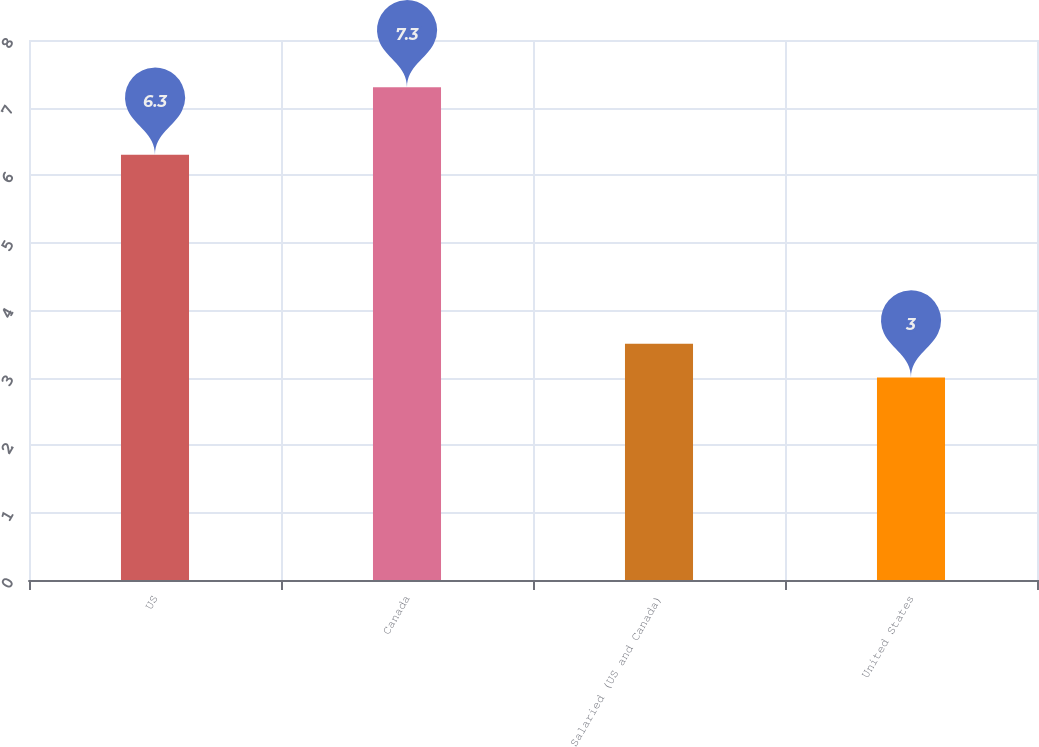<chart> <loc_0><loc_0><loc_500><loc_500><bar_chart><fcel>US<fcel>Canada<fcel>Salaried (US and Canada)<fcel>United States<nl><fcel>6.3<fcel>7.3<fcel>3.5<fcel>3<nl></chart> 